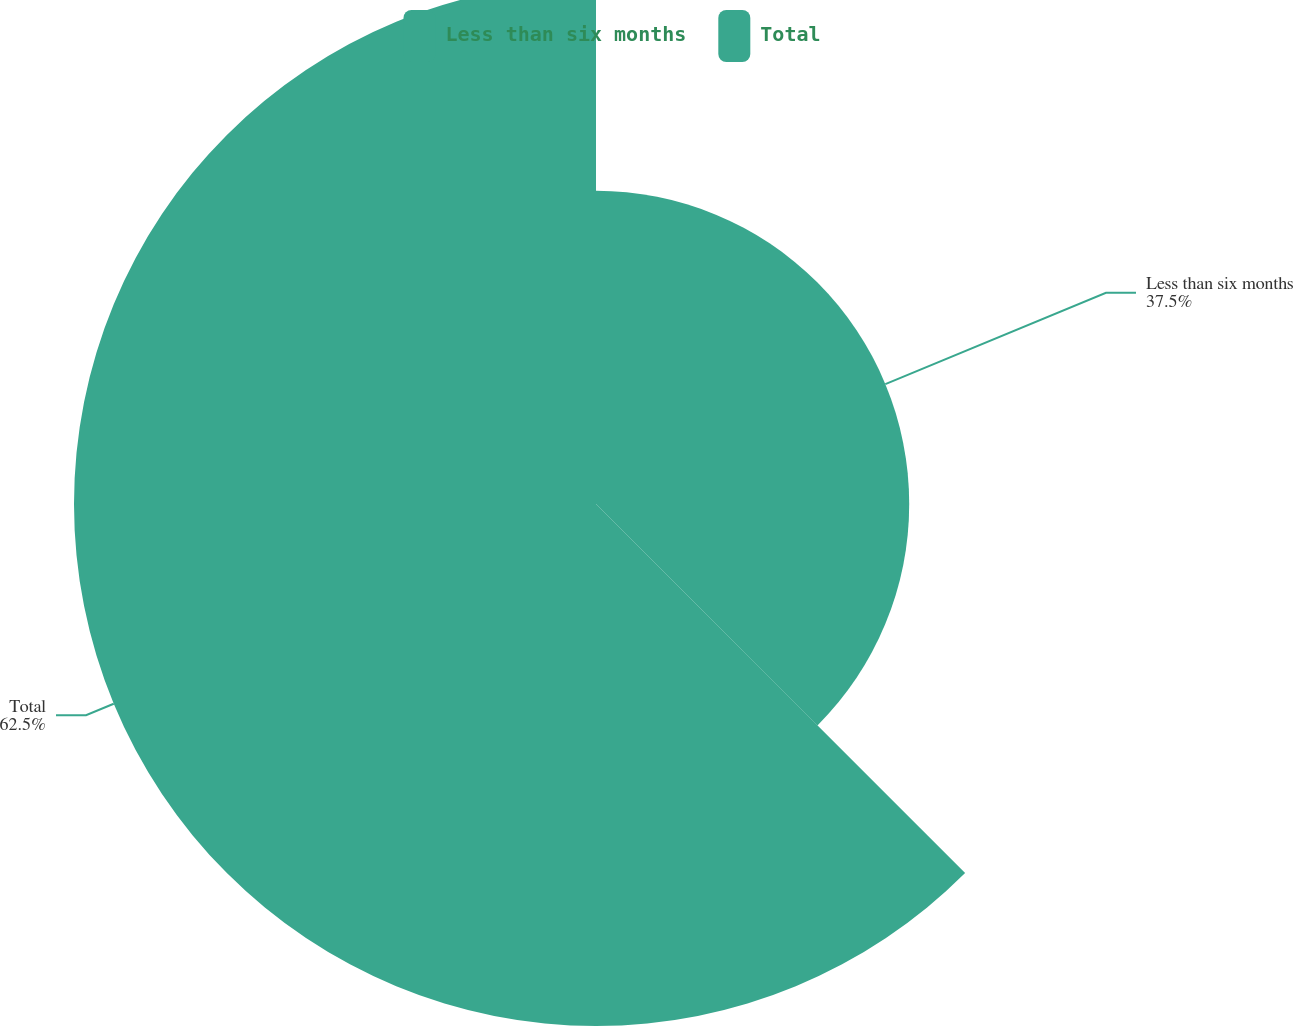Convert chart to OTSL. <chart><loc_0><loc_0><loc_500><loc_500><pie_chart><fcel>Less than six months<fcel>Total<nl><fcel>37.5%<fcel>62.5%<nl></chart> 